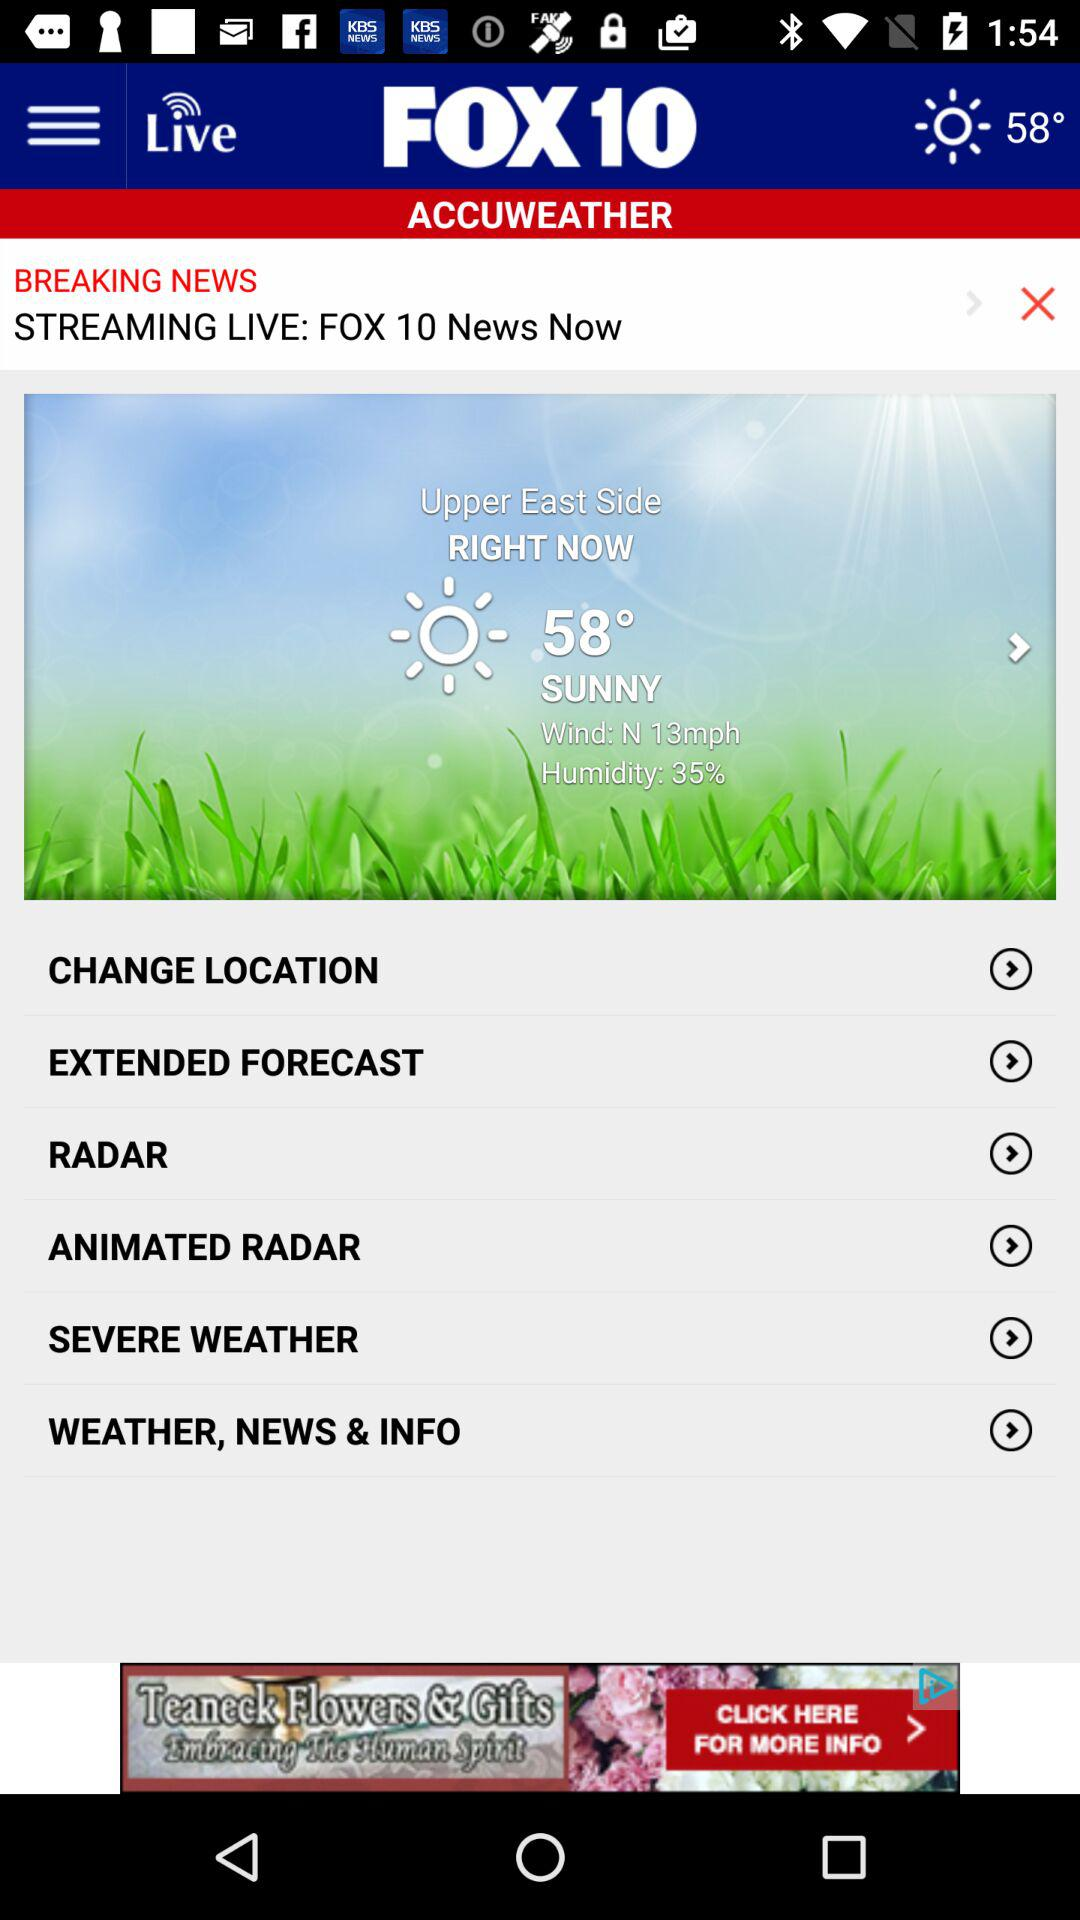How many degrees Fahrenheit is the current temperature?
Answer the question using a single word or phrase. 58° 